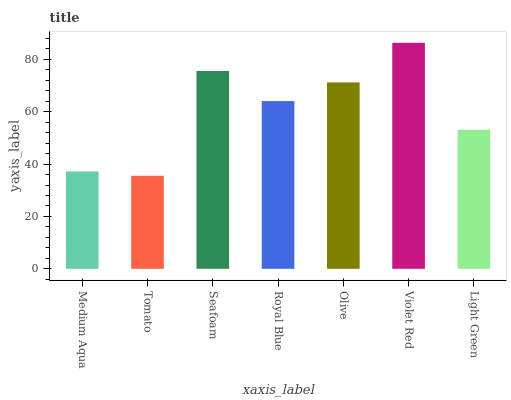Is Tomato the minimum?
Answer yes or no. Yes. Is Violet Red the maximum?
Answer yes or no. Yes. Is Seafoam the minimum?
Answer yes or no. No. Is Seafoam the maximum?
Answer yes or no. No. Is Seafoam greater than Tomato?
Answer yes or no. Yes. Is Tomato less than Seafoam?
Answer yes or no. Yes. Is Tomato greater than Seafoam?
Answer yes or no. No. Is Seafoam less than Tomato?
Answer yes or no. No. Is Royal Blue the high median?
Answer yes or no. Yes. Is Royal Blue the low median?
Answer yes or no. Yes. Is Seafoam the high median?
Answer yes or no. No. Is Olive the low median?
Answer yes or no. No. 